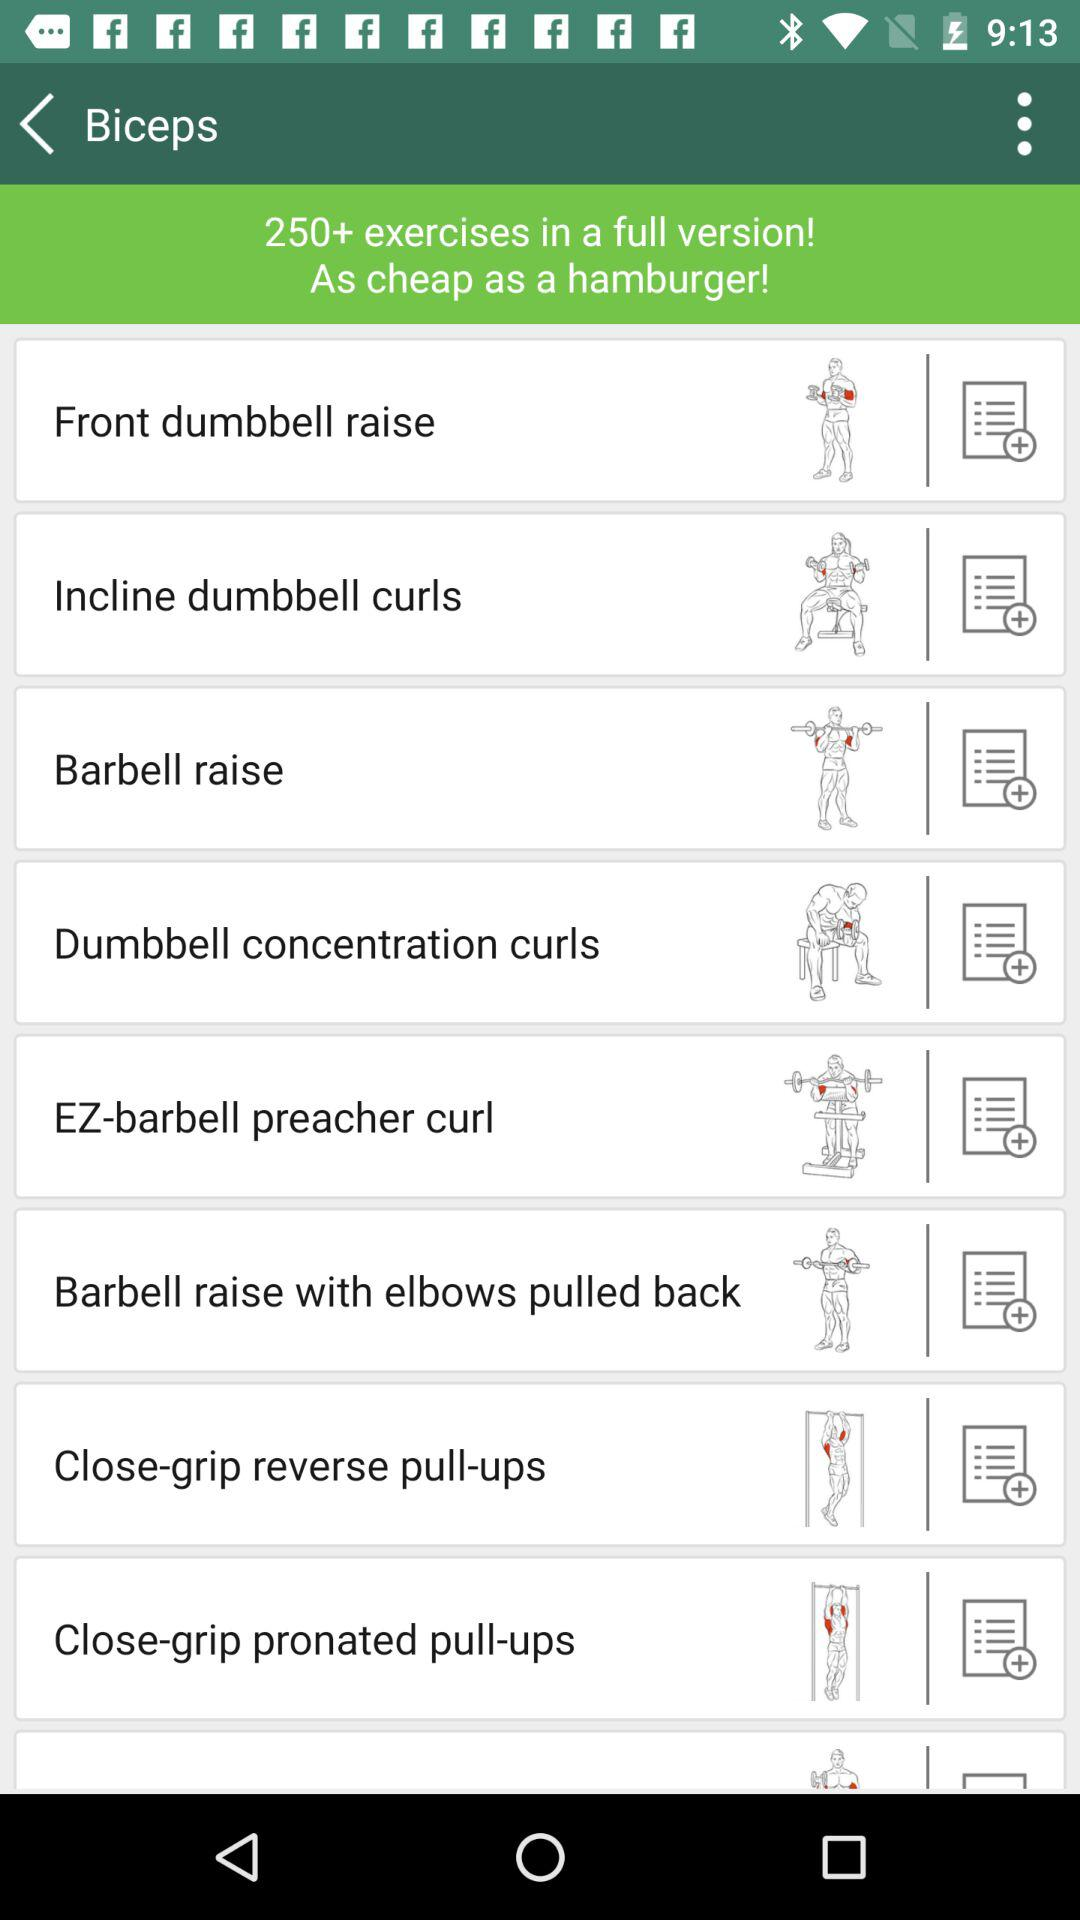How many total exercises are there? There are more than 250 exercises. 